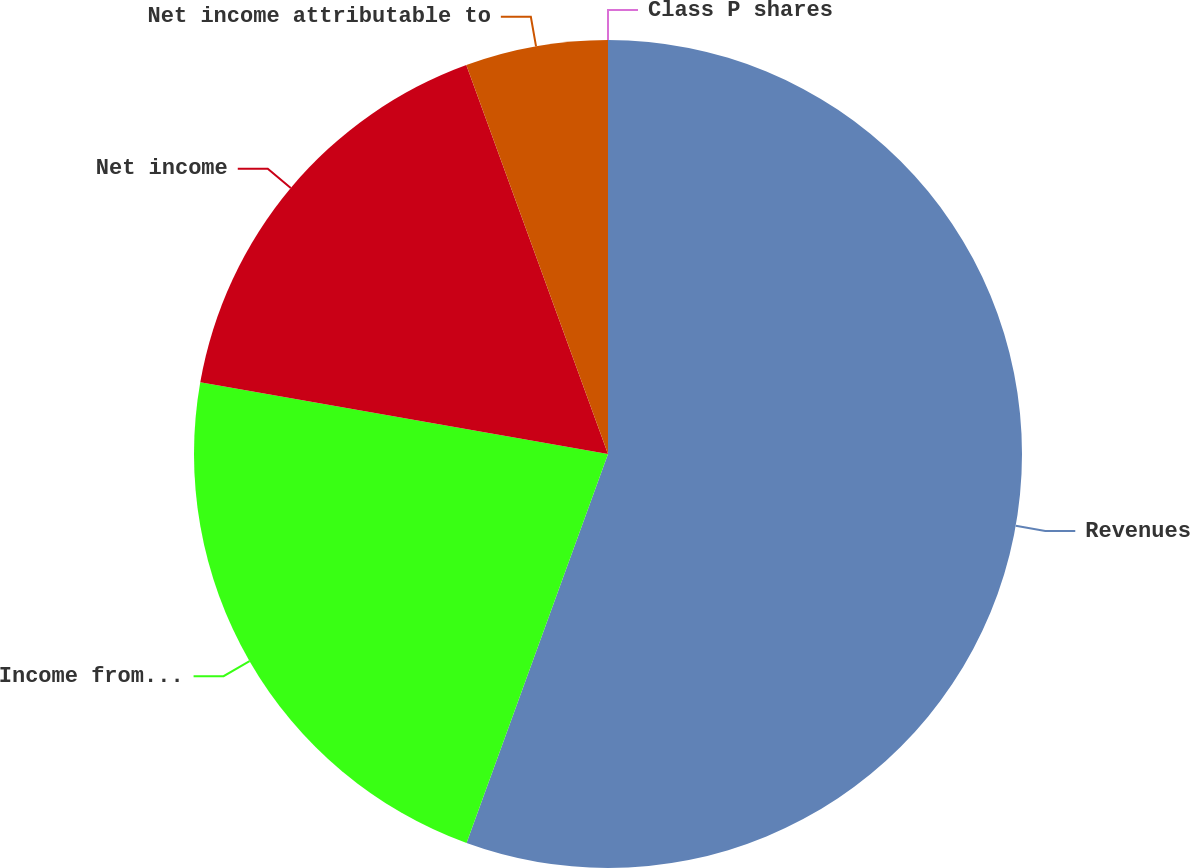<chart> <loc_0><loc_0><loc_500><loc_500><pie_chart><fcel>Revenues<fcel>Income from continuing<fcel>Net income<fcel>Net income attributable to<fcel>Class P shares<nl><fcel>55.55%<fcel>22.22%<fcel>16.67%<fcel>5.56%<fcel>0.0%<nl></chart> 